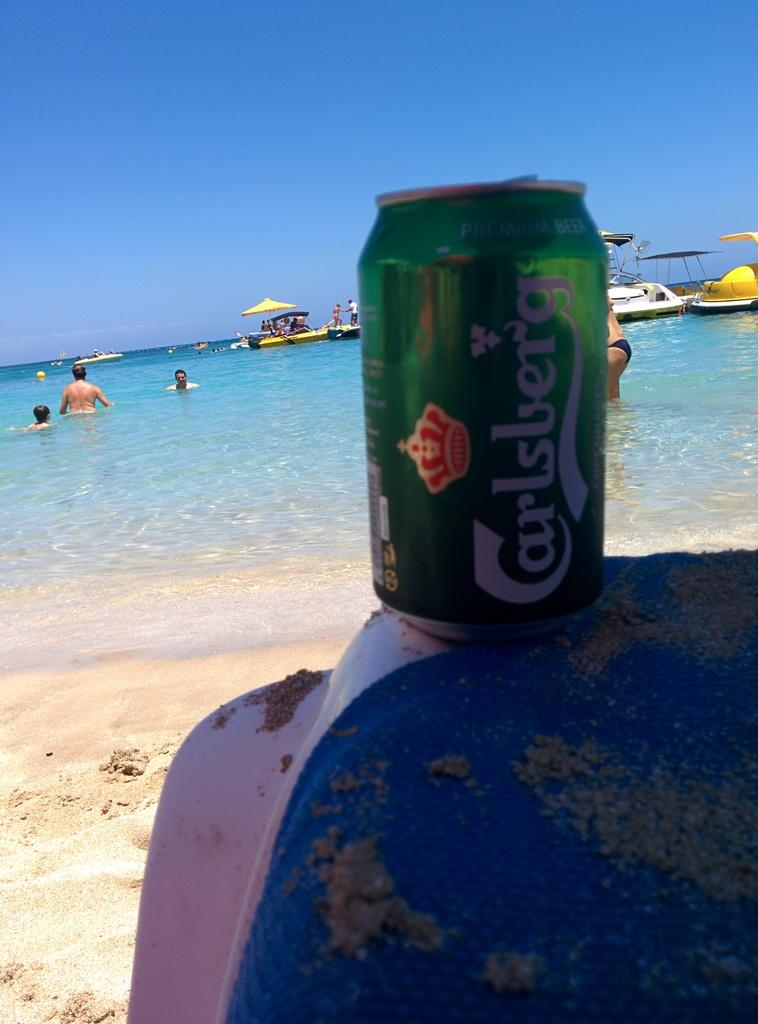<image>
Offer a succinct explanation of the picture presented. a can that had the word Carlsberg on it 